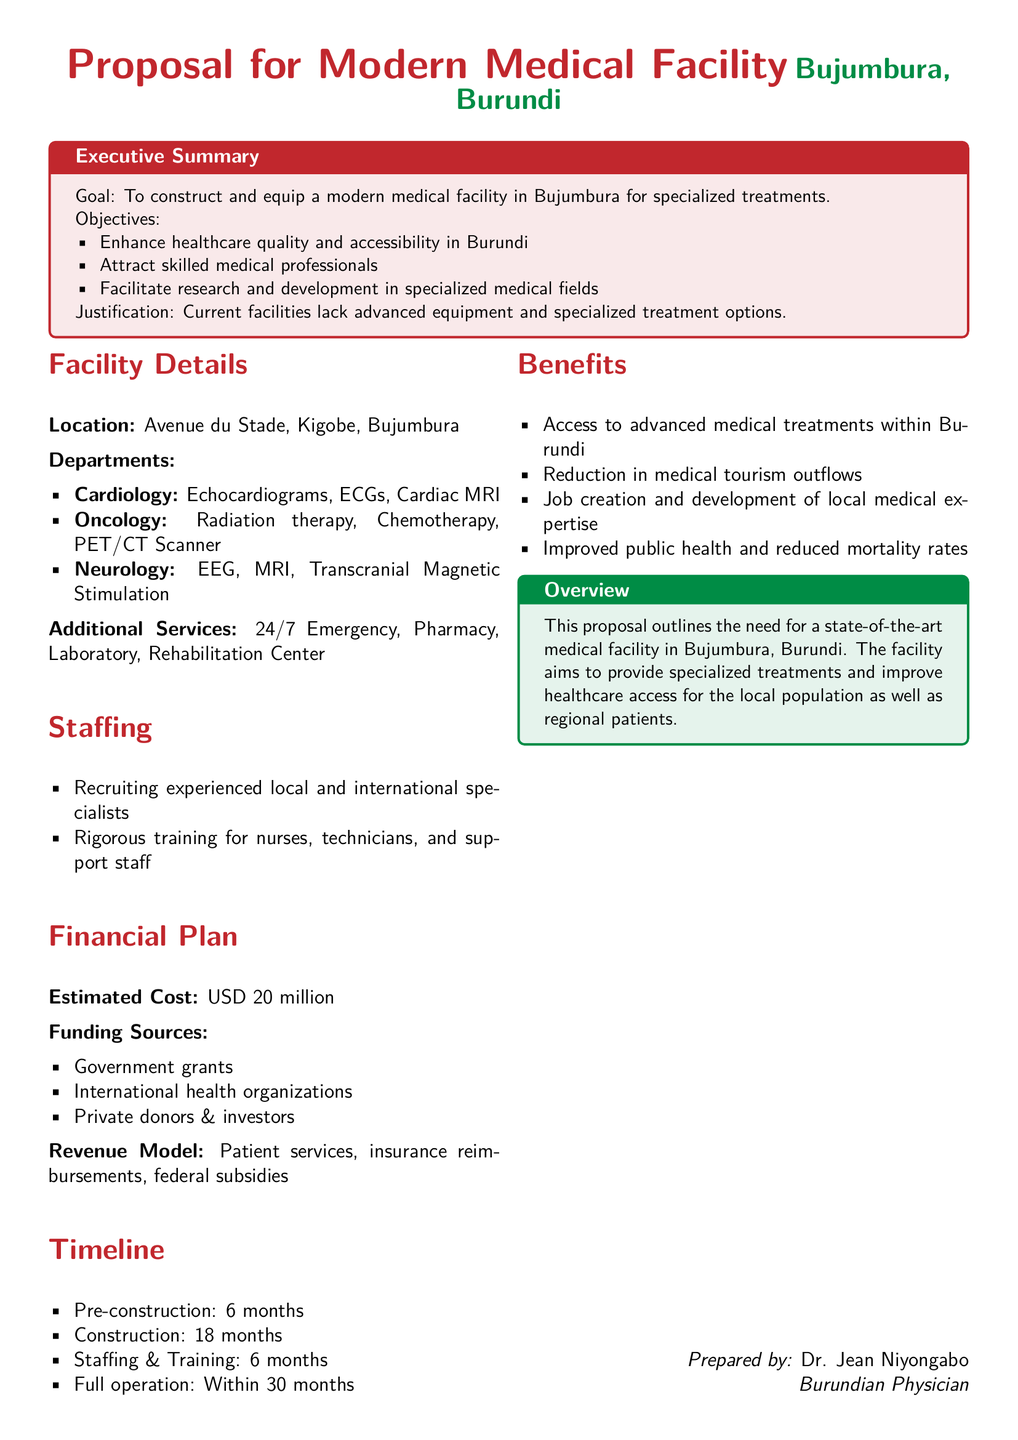what is the estimated cost of the modern medical facility? The estimated cost is specifically mentioned in the financial plan section of the document.
Answer: USD 20 million what departments are included in the facility? The document lists the departments under the facility details section that provide specialized treatments.
Answer: Cardiology, Oncology, Neurology how long is the construction phase expected to last? The construction duration is mentioned in the timeline section, indicating the effort required to complete that phase.
Answer: 18 months what additional services will the facility provide? The document specifies extra services available in the facility under the facility details section.
Answer: 24/7 Emergency, Pharmacy, Laboratory, Rehabilitation Center who is responsible for preparing this proposal? The document notes the preparer at the bottom, providing information about authorship.
Answer: Dr. Jean Niyongabo what is the goal of constructing the medical facility? The goal of the facility is defined in the executive summary, focusing on the primary aim of the project.
Answer: Enhance healthcare quality and accessibility in Burundi which funding sources are listed for the financial plan? The document outlines potential funding sources under the financial plan section that will support the project financially.
Answer: Government grants, International health organizations, Private donors & investors what is the total time to achieve full operation? The total time frame to achieve full operation is stated in the timeline section of the proposal.
Answer: Within 30 months 